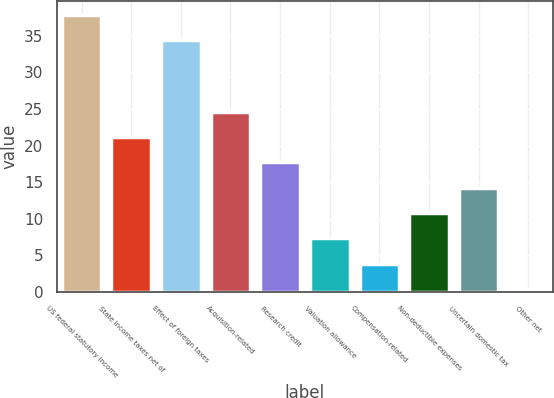Convert chart. <chart><loc_0><loc_0><loc_500><loc_500><bar_chart><fcel>US federal statutory income<fcel>State income taxes net of<fcel>Effect of foreign taxes<fcel>Acquisition-related<fcel>Research credit<fcel>Valuation allowance<fcel>Compensation-related<fcel>Non-deductible expenses<fcel>Uncertain domestic tax<fcel>Other net<nl><fcel>37.86<fcel>21.16<fcel>34.4<fcel>24.62<fcel>17.7<fcel>7.32<fcel>3.86<fcel>10.78<fcel>14.24<fcel>0.4<nl></chart> 